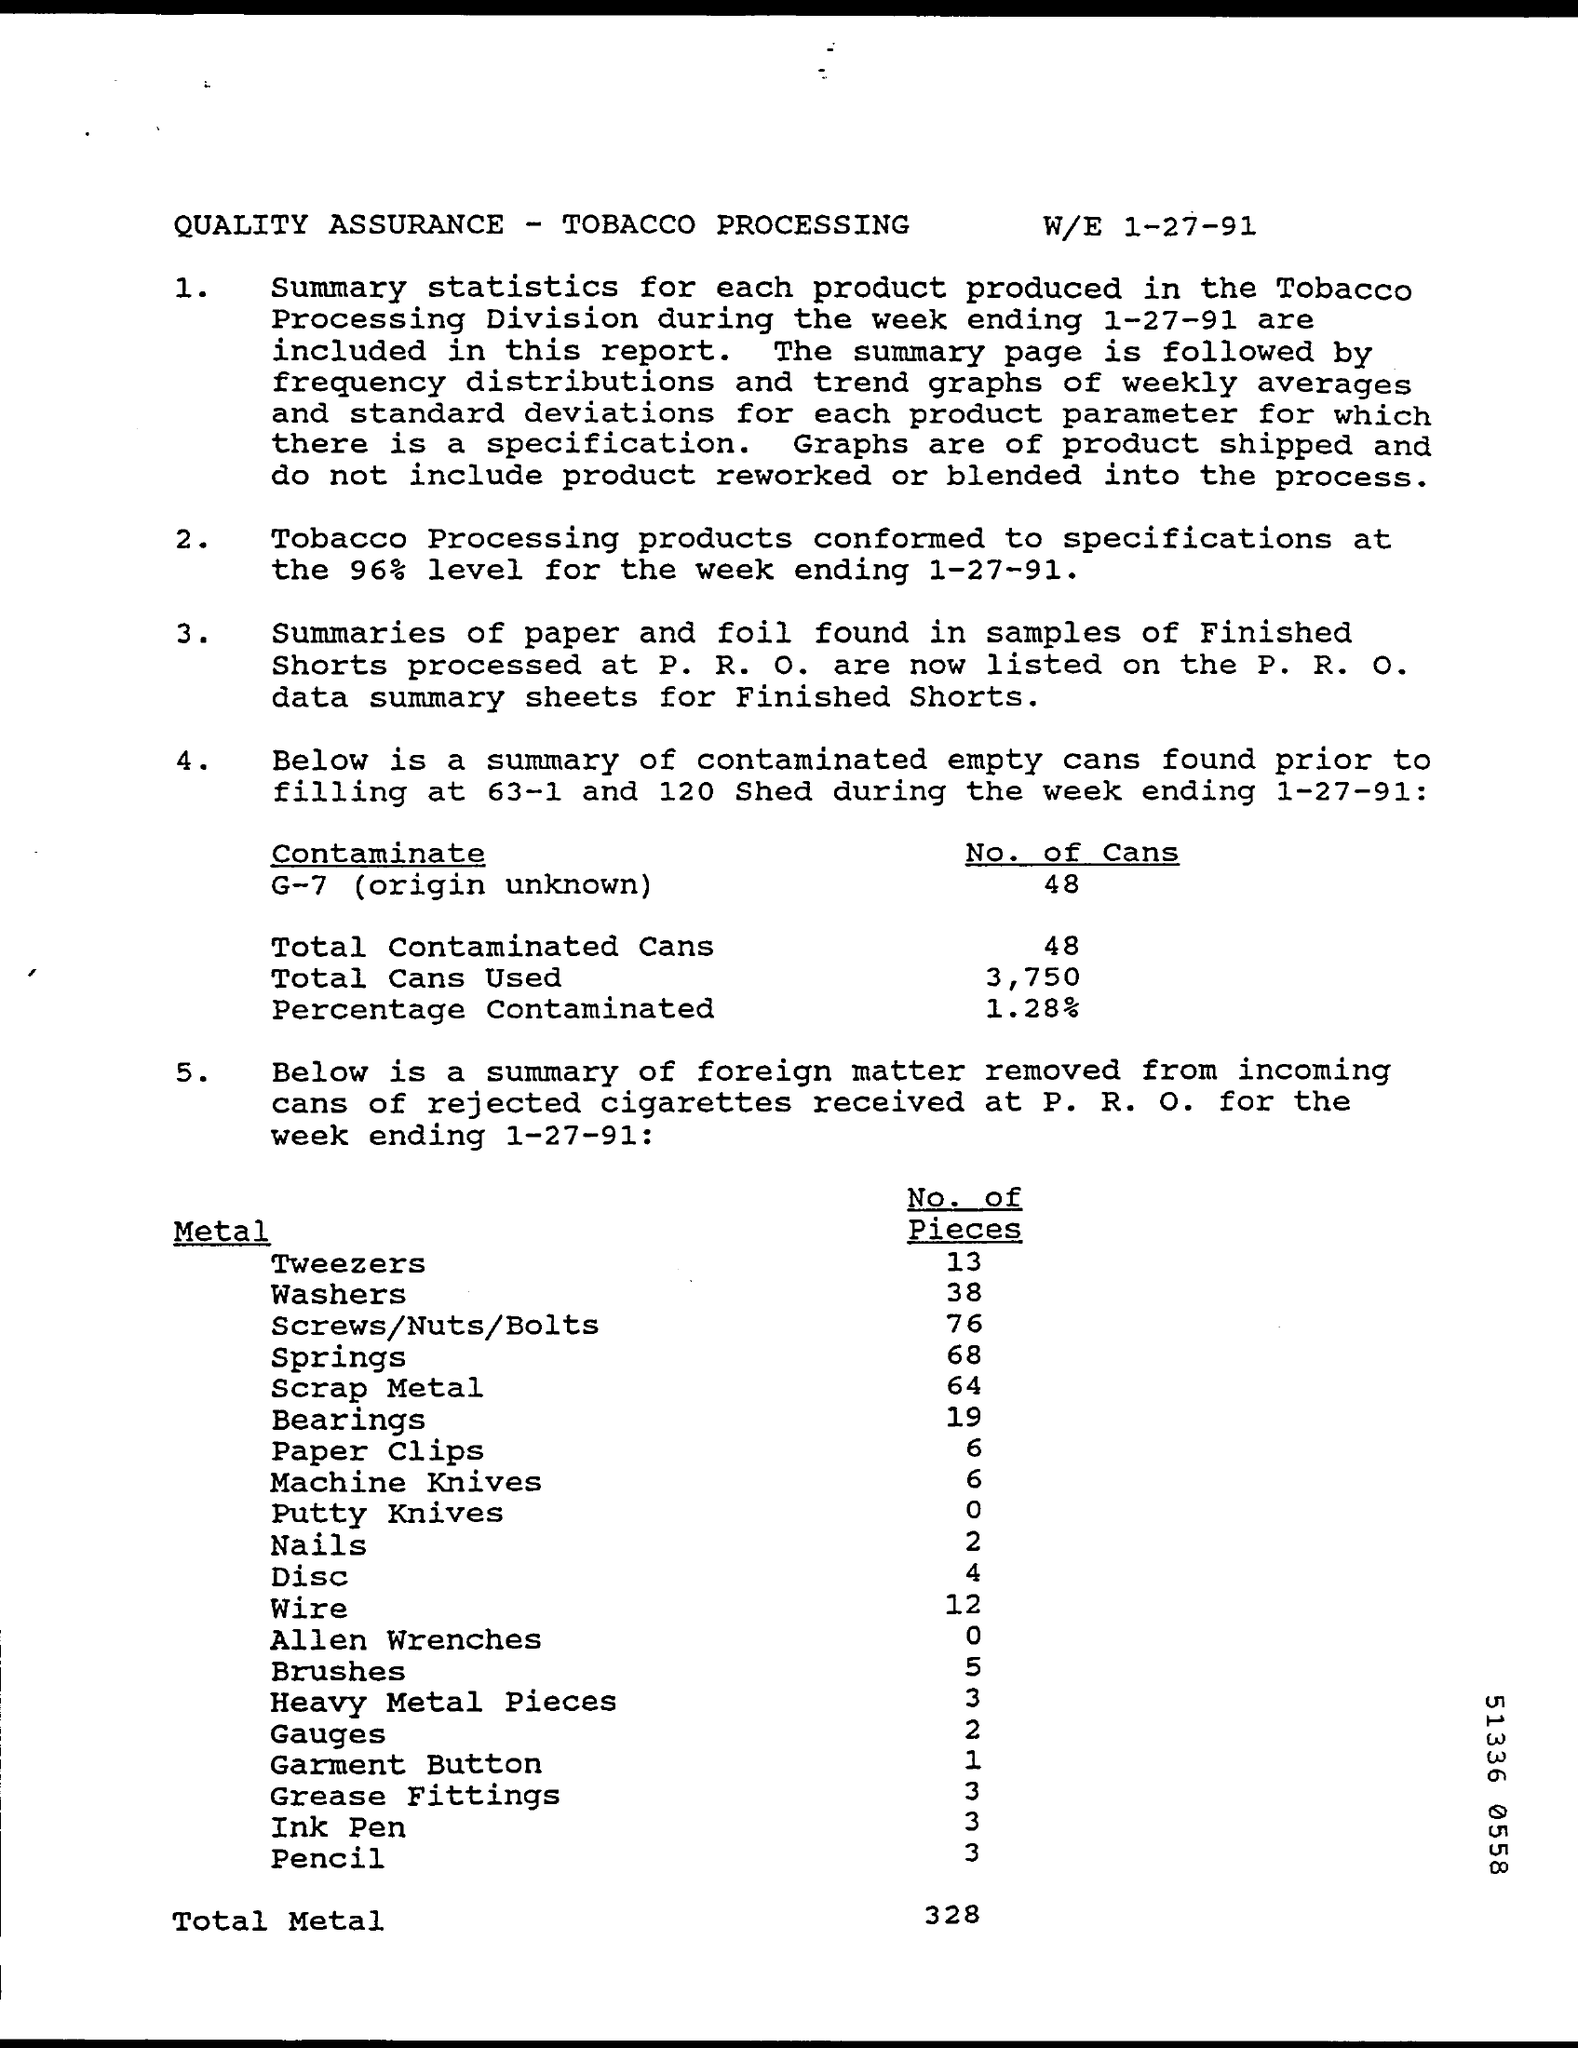Point out several critical features in this image. The title of the document is "QUALITY ASSURANCE - TOBACCO PROCESSING". The number of pieces of nails is two. A total of 3,750 cans have been used. The number of contaminated cans of G-7 is 48. The number of pieces of washers is 38. 